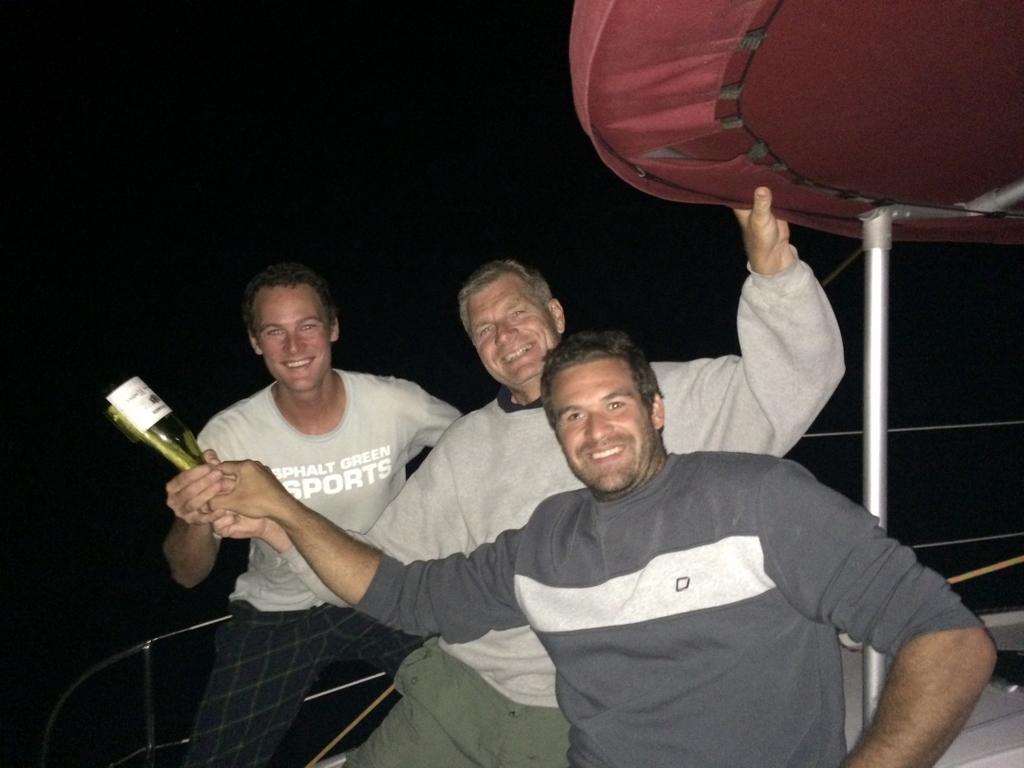Can you describe this image briefly? Here in this picture we can see three men are standing and smiling. In their hands there is a bottle. The middle man is holding a red color tint in his hand. They are on the boat. 